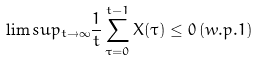Convert formula to latex. <formula><loc_0><loc_0><loc_500><loc_500>\lim s u p _ { t \rightarrow \infty } \frac { 1 } { t } \sum _ { \tau = 0 } ^ { t - 1 } X ( \tau ) \leq 0 \, ( w . p . 1 )</formula> 